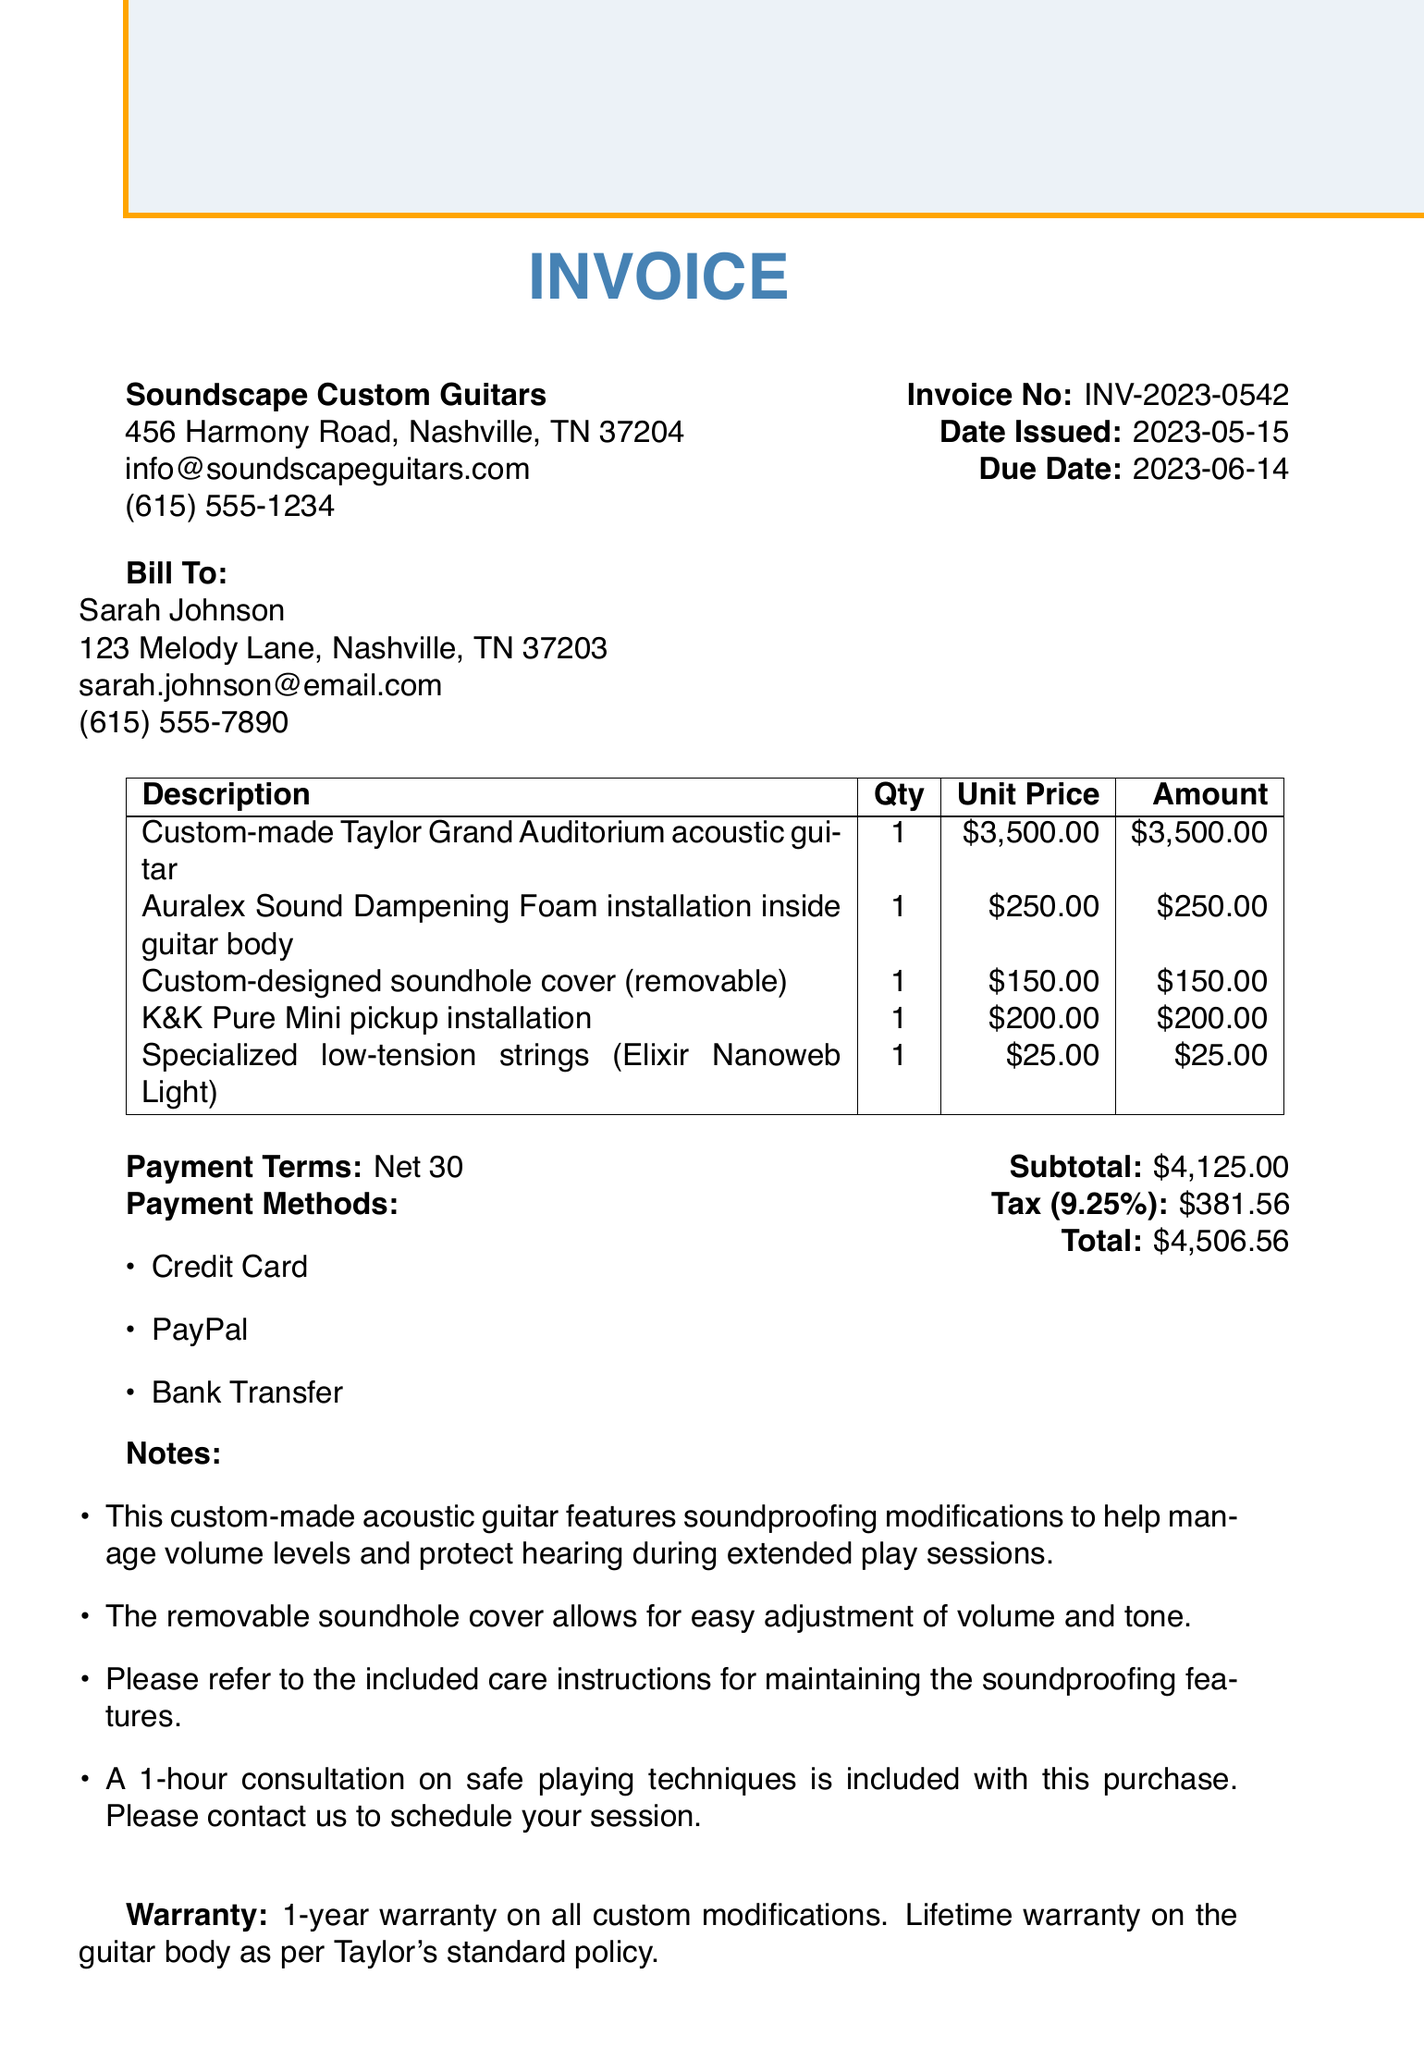what is the invoice number? The invoice number is a unique identifier for the transaction, which is listed in the document.
Answer: INV-2023-0542 who is the customer? The customer information section provides the name of the person making the purchase.
Answer: Sarah Johnson what is the due date for payment? The due date indicates when the payment for the invoice is expected.
Answer: 2023-06-14 how much is the tax amount? The tax amount is a specific figure calculated based on the subtotal provided in the document.
Answer: 381.56 what is included with the purchase of the guitar? This refers to any additional services or products provided along with the main item purchased, as noted in the document.
Answer: A 1-hour consultation on safe playing techniques how many items are included in the invoice? The number of items refers to how many distinct products or services are listed in the invoice.
Answer: 5 what is the warranty period for custom modifications? The warranty period indicates how long the custom modifications are covered under warranty as stated in the document.
Answer: 1-year what is the total amount due? The total amount due is the final figure that the customer needs to pay, which is detailed in the invoice.
Answer: 4506.56 what are the payment methods accepted? The payment methods section lists the ways the customer can pay for the invoice, according to the document.
Answer: Credit Card, PayPal, Bank Transfer 